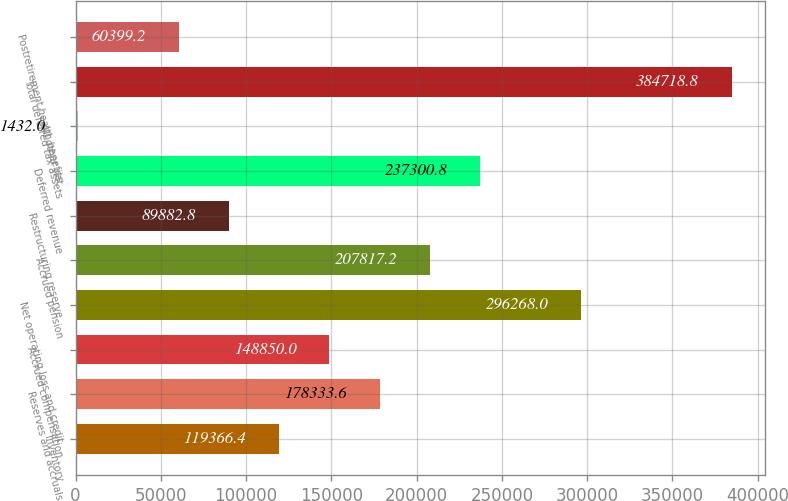<chart> <loc_0><loc_0><loc_500><loc_500><bar_chart><fcel>Inventory<fcel>Reserves and accruals<fcel>Accrued compensation<fcel>Net operating loss and credit<fcel>Accrued pension<fcel>Restructuring reserve<fcel>Deferred revenue<fcel>All other net<fcel>Total deferred tax assets<fcel>Postretirement health benefits<nl><fcel>119366<fcel>178334<fcel>148850<fcel>296268<fcel>207817<fcel>89882.8<fcel>237301<fcel>1432<fcel>384719<fcel>60399.2<nl></chart> 